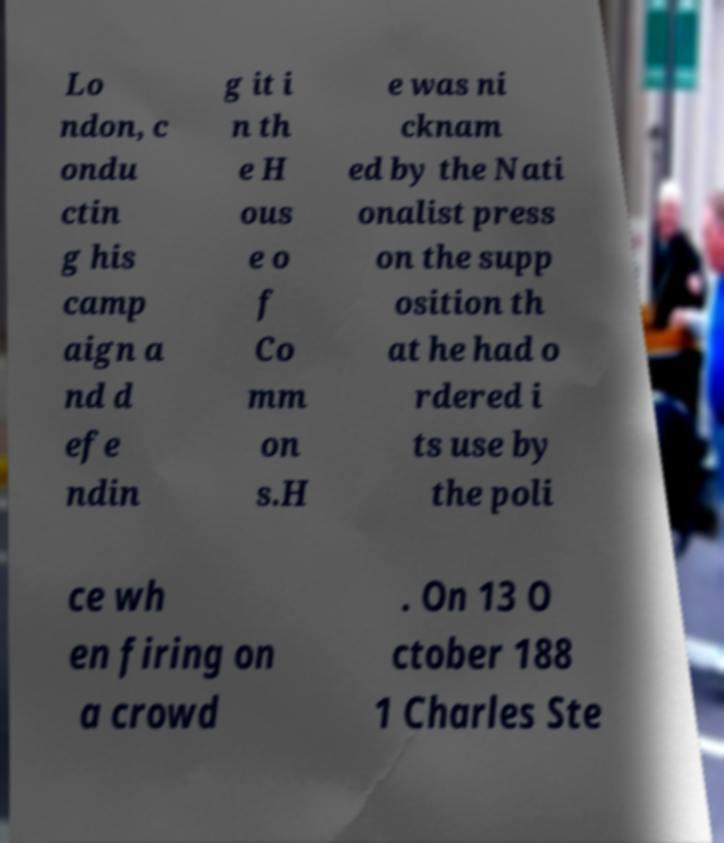Could you extract and type out the text from this image? Lo ndon, c ondu ctin g his camp aign a nd d efe ndin g it i n th e H ous e o f Co mm on s.H e was ni cknam ed by the Nati onalist press on the supp osition th at he had o rdered i ts use by the poli ce wh en firing on a crowd . On 13 O ctober 188 1 Charles Ste 